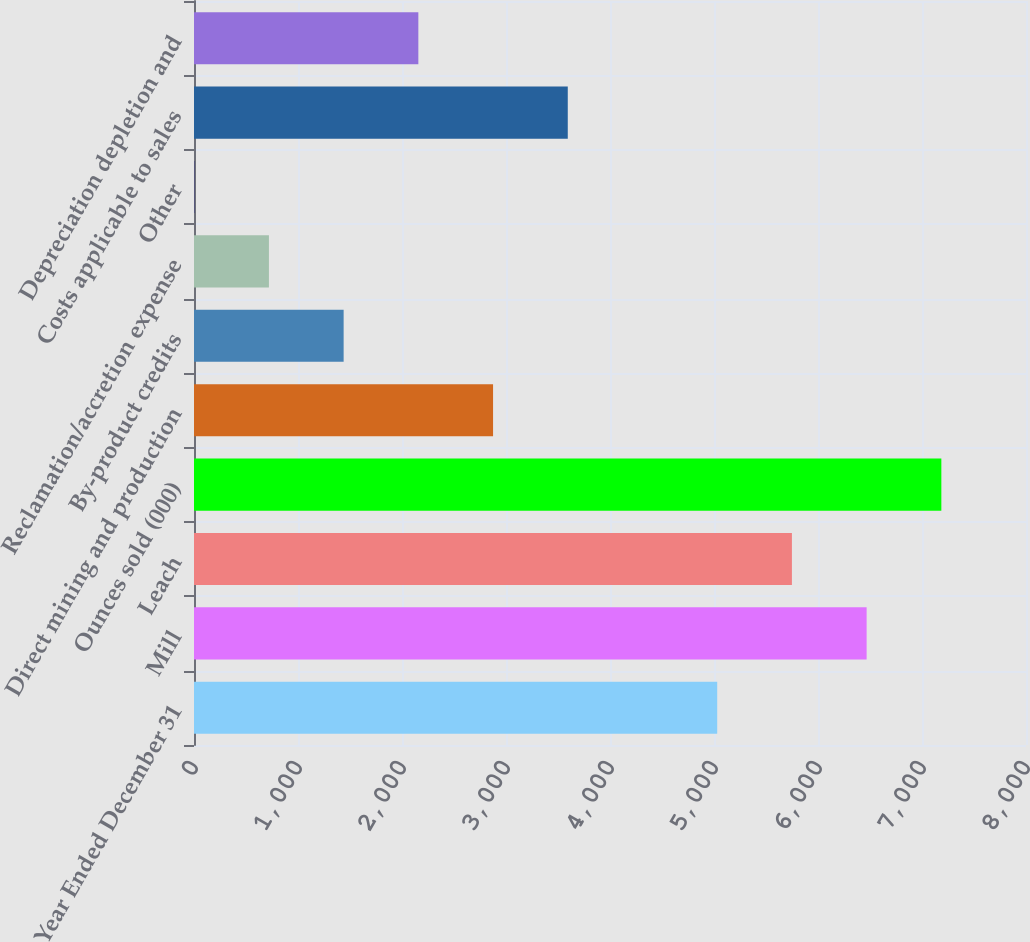Convert chart. <chart><loc_0><loc_0><loc_500><loc_500><bar_chart><fcel>Year Ended December 31<fcel>Mill<fcel>Leach<fcel>Ounces sold (000)<fcel>Direct mining and production<fcel>By-product credits<fcel>Reclamation/accretion expense<fcel>Other<fcel>Costs applicable to sales<fcel>Depreciation depletion and<nl><fcel>5030.8<fcel>6467.6<fcel>5749.2<fcel>7186<fcel>2875.6<fcel>1438.8<fcel>720.4<fcel>2<fcel>3594<fcel>2157.2<nl></chart> 